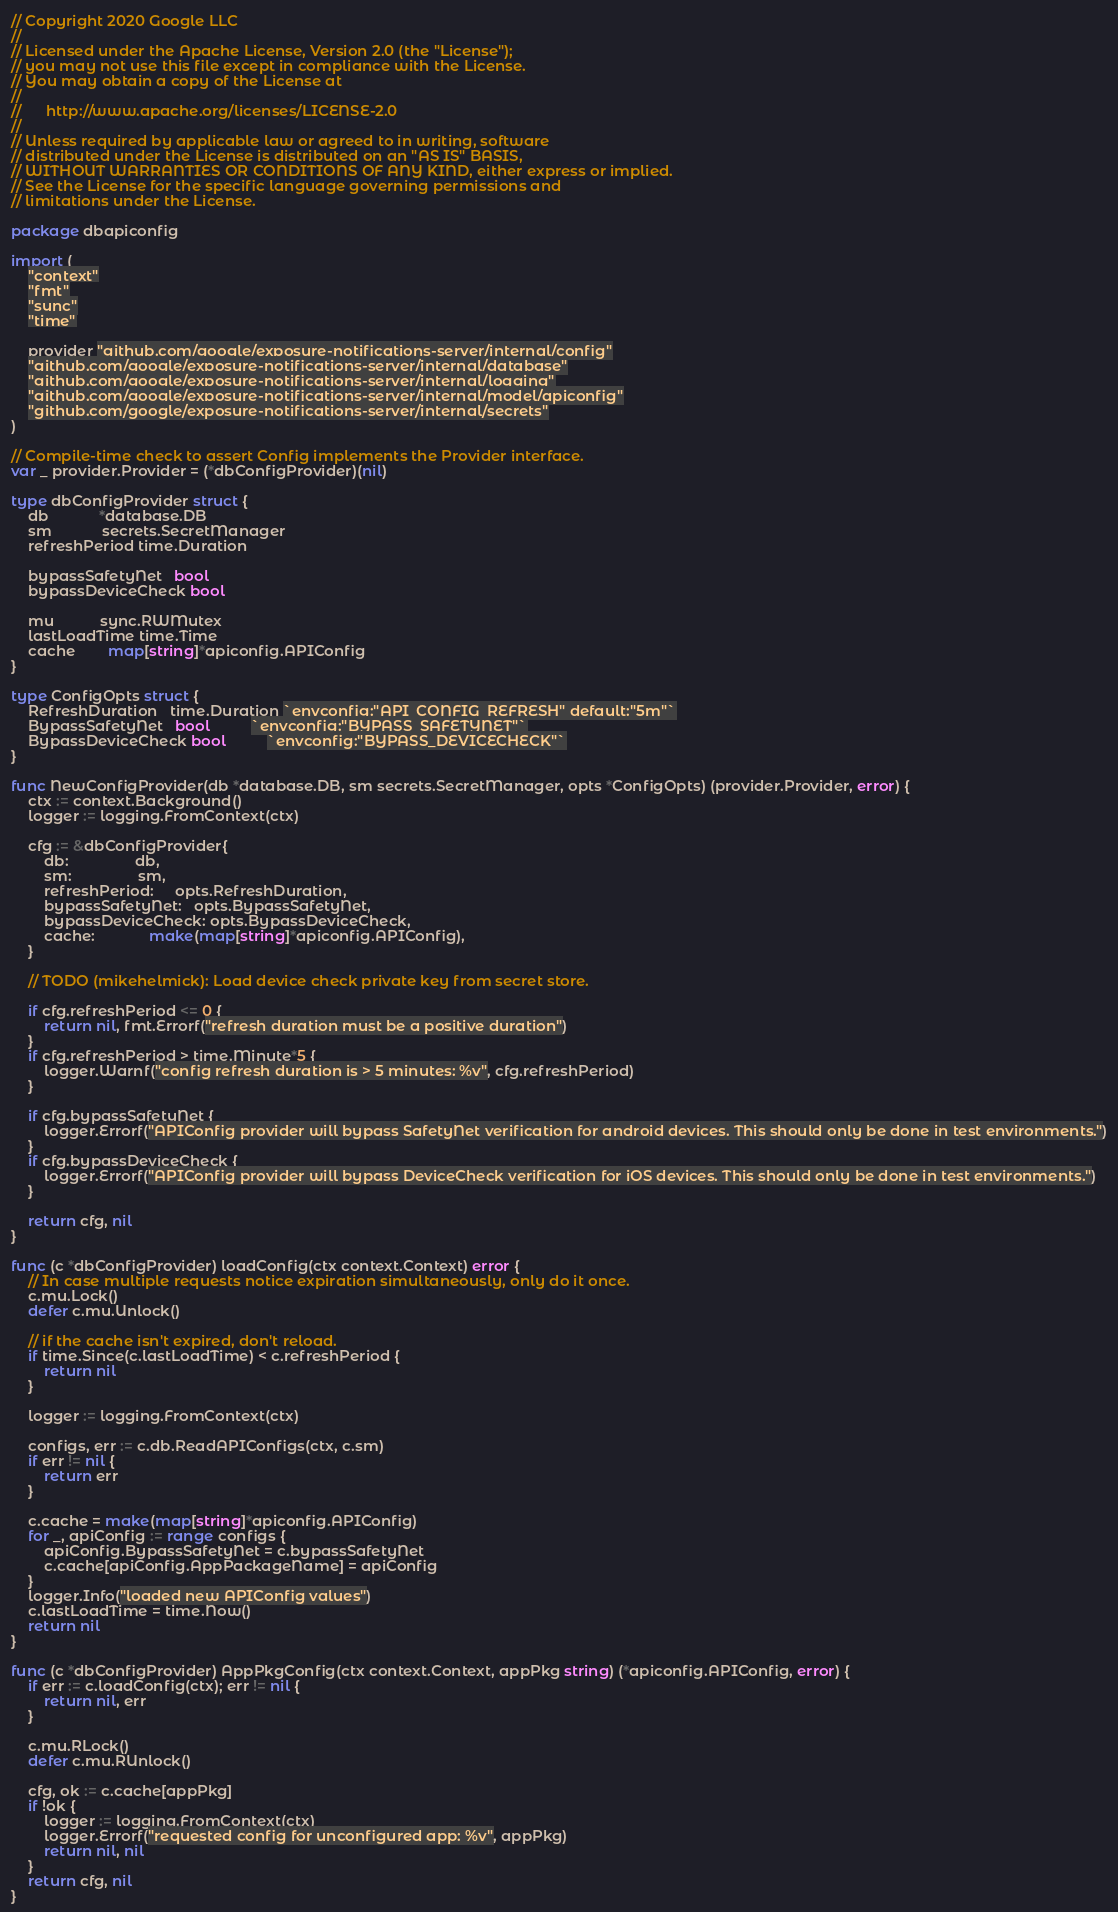Convert code to text. <code><loc_0><loc_0><loc_500><loc_500><_Go_>// Copyright 2020 Google LLC
//
// Licensed under the Apache License, Version 2.0 (the "License");
// you may not use this file except in compliance with the License.
// You may obtain a copy of the License at
//
//      http://www.apache.org/licenses/LICENSE-2.0
//
// Unless required by applicable law or agreed to in writing, software
// distributed under the License is distributed on an "AS IS" BASIS,
// WITHOUT WARRANTIES OR CONDITIONS OF ANY KIND, either express or implied.
// See the License for the specific language governing permissions and
// limitations under the License.

package dbapiconfig

import (
	"context"
	"fmt"
	"sync"
	"time"

	provider "github.com/google/exposure-notifications-server/internal/config"
	"github.com/google/exposure-notifications-server/internal/database"
	"github.com/google/exposure-notifications-server/internal/logging"
	"github.com/google/exposure-notifications-server/internal/model/apiconfig"
	"github.com/google/exposure-notifications-server/internal/secrets"
)

// Compile-time check to assert Config implements the Provider interface.
var _ provider.Provider = (*dbConfigProvider)(nil)

type dbConfigProvider struct {
	db            *database.DB
	sm            secrets.SecretManager
	refreshPeriod time.Duration

	bypassSafetyNet   bool
	bypassDeviceCheck bool

	mu           sync.RWMutex
	lastLoadTime time.Time
	cache        map[string]*apiconfig.APIConfig
}

type ConfigOpts struct {
	RefreshDuration   time.Duration `envconfig:"API_CONFIG_REFRESH" default:"5m"`
	BypassSafetyNet   bool          `envconfig:"BYPASS_SAFETYNET"`
	BypassDeviceCheck bool          `envconfig:"BYPASS_DEVICECHECK"`
}

func NewConfigProvider(db *database.DB, sm secrets.SecretManager, opts *ConfigOpts) (provider.Provider, error) {
	ctx := context.Background()
	logger := logging.FromContext(ctx)

	cfg := &dbConfigProvider{
		db:                db,
		sm:                sm,
		refreshPeriod:     opts.RefreshDuration,
		bypassSafetyNet:   opts.BypassSafetyNet,
		bypassDeviceCheck: opts.BypassDeviceCheck,
		cache:             make(map[string]*apiconfig.APIConfig),
	}

	// TODO (mikehelmick): Load device check private key from secret store.

	if cfg.refreshPeriod <= 0 {
		return nil, fmt.Errorf("refresh duration must be a positive duration")
	}
	if cfg.refreshPeriod > time.Minute*5 {
		logger.Warnf("config refresh duration is > 5 minutes: %v", cfg.refreshPeriod)
	}

	if cfg.bypassSafetyNet {
		logger.Errorf("APIConfig provider will bypass SafetyNet verification for android devices. This should only be done in test environments.")
	}
	if cfg.bypassDeviceCheck {
		logger.Errorf("APIConfig provider will bypass DeviceCheck verification for iOS devices. This should only be done in test environments.")
	}

	return cfg, nil
}

func (c *dbConfigProvider) loadConfig(ctx context.Context) error {
	// In case multiple requests notice expiration simultaneously, only do it once.
	c.mu.Lock()
	defer c.mu.Unlock()

	// if the cache isn't expired, don't reload.
	if time.Since(c.lastLoadTime) < c.refreshPeriod {
		return nil
	}

	logger := logging.FromContext(ctx)

	configs, err := c.db.ReadAPIConfigs(ctx, c.sm)
	if err != nil {
		return err
	}

	c.cache = make(map[string]*apiconfig.APIConfig)
	for _, apiConfig := range configs {
		apiConfig.BypassSafetyNet = c.bypassSafetyNet
		c.cache[apiConfig.AppPackageName] = apiConfig
	}
	logger.Info("loaded new APIConfig values")
	c.lastLoadTime = time.Now()
	return nil
}

func (c *dbConfigProvider) AppPkgConfig(ctx context.Context, appPkg string) (*apiconfig.APIConfig, error) {
	if err := c.loadConfig(ctx); err != nil {
		return nil, err
	}

	c.mu.RLock()
	defer c.mu.RUnlock()

	cfg, ok := c.cache[appPkg]
	if !ok {
		logger := logging.FromContext(ctx)
		logger.Errorf("requested config for unconfigured app: %v", appPkg)
		return nil, nil
	}
	return cfg, nil
}
</code> 